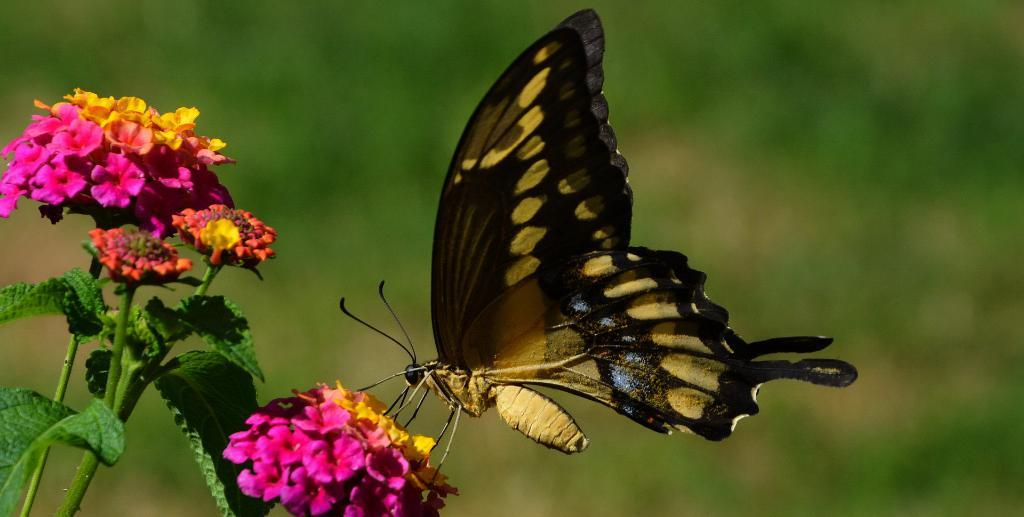What is the main subject of the picture? The main subject of the picture is a butterfly. Can you describe the colors of the butterfly? The butterfly has yellow and black colors. What is the butterfly sitting on in the picture? The butterfly is sitting on a pink flower plant. How would you describe the background of the image? The background of the image is blurred. What type of jeans is the butterfly wearing in the image? There are no jeans present in the image, as butterflies do not wear clothing. 